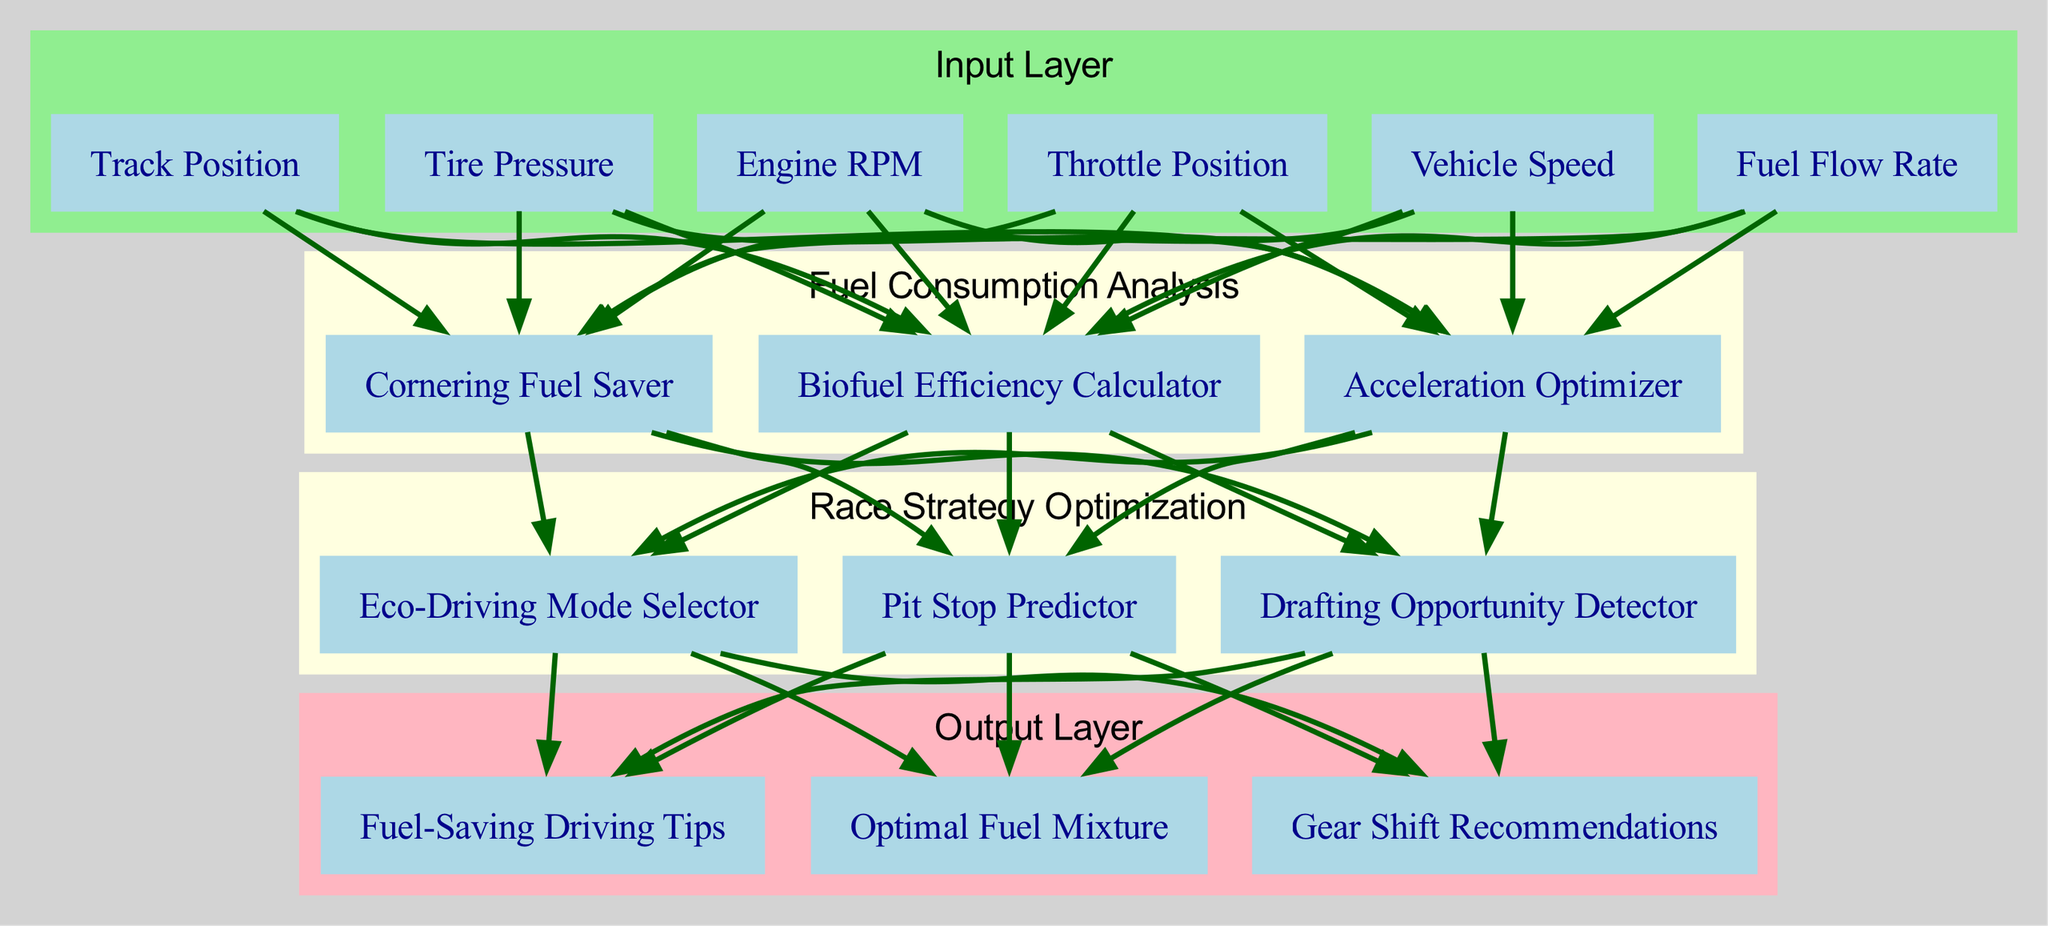What are the nodes in the input layer? The input layer contains six nodes: Engine RPM, Throttle Position, Vehicle Speed, Fuel Flow Rate, Track Position, and Tire Pressure.
Answer: Engine RPM, Throttle Position, Vehicle Speed, Fuel Flow Rate, Track Position, Tire Pressure How many nodes are there in the "Fuel Consumption Analysis" hidden layer? The "Fuel Consumption Analysis" hidden layer consists of three nodes: Biofuel Efficiency Calculator, Acceleration Optimizer, and Cornering Fuel Saver. Therefore, the number of nodes is three.
Answer: 3 What is the connection from "Fuel Consumption Analysis" to "Race Strategy Optimization"? The connection indicates that the output from the "Fuel Consumption Analysis" layer is fed into the "Race Strategy Optimization" layer, meaning that it passes along information for further processing.
Answer: Yes Which output node is related to fuel efficiency? The output node related to fuel efficiency is "Optimal Fuel Mixture," which suggests the optimized fuel composition for maximum efficiency during races.
Answer: Optimal Fuel Mixture How many total connections are there in the diagram? There is a total of five connections: three inputs connected to the first hidden layer, three connections from the first hidden layer to the second hidden layer, and three connections from the second hidden layer to the output layer.
Answer: 5 What is the last node in the processing flow? The last node in the processing flow is "Fuel-Saving Driving Tips," which suggests driving strategies that enhance fuel savings based on the processed data.
Answer: Fuel-Saving Driving Tips Which hidden layer contributes to pit stop predictions? The "Race Strategy Optimization" hidden layer contributes to pit stop predictions, with the specific node being "Pit Stop Predictor" that evaluates the need for pit stops based on data.
Answer: Race Strategy Optimization What is the main purpose of the "Biofuel Efficiency Calculator"? The main purpose of the "Biofuel Efficiency Calculator" is to analyze the efficiency of biofuels used in the race car engine to promote sustainable racing practices.
Answer: Biofuel Efficiency Calculator 